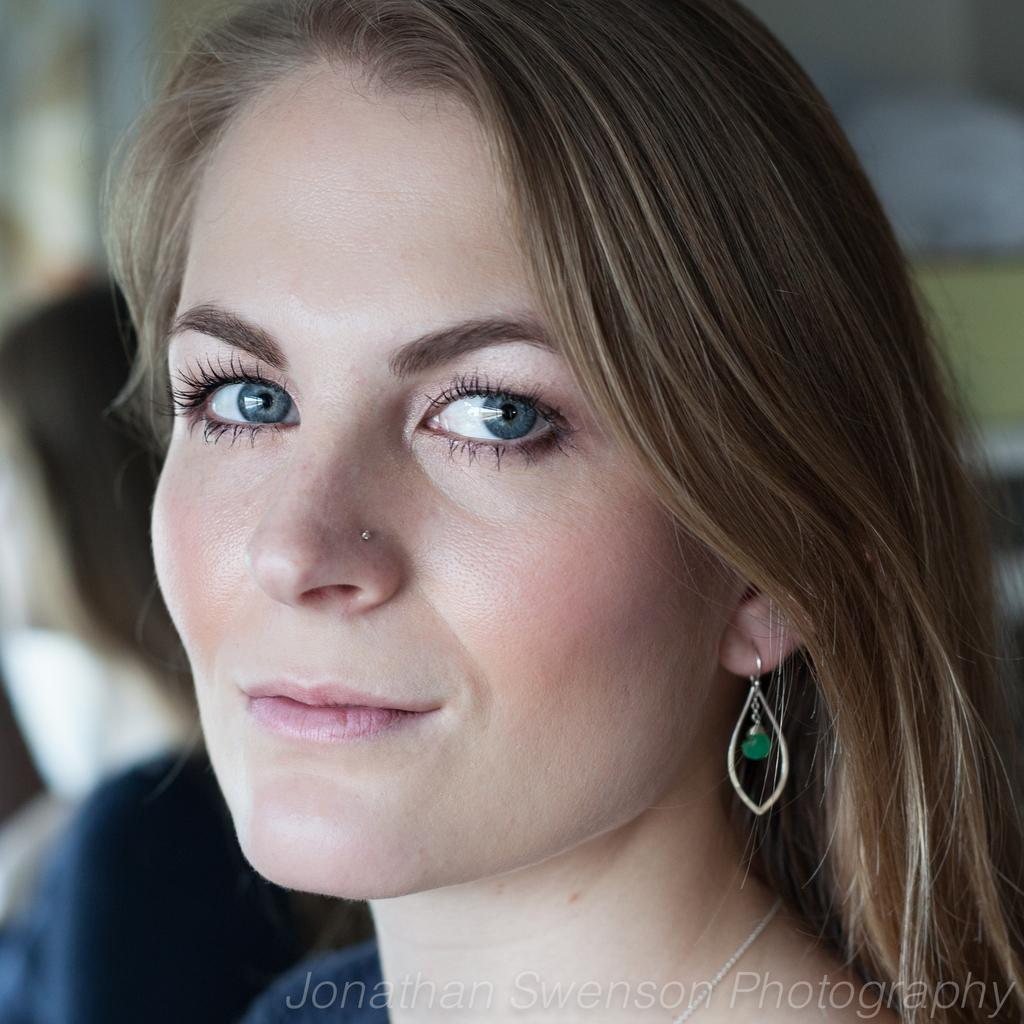Who is present in the image? There is a woman in the image. What is the woman's facial expression? The woman is smiling. What type of jewelry is the woman wearing? The woman is wearing a nose ring and an earring. How would you describe the background of the image? The background of the image appears blurry. Can you identify any additional features of the image? There is a watermark on the image. What type of drink does the woman hate in the image? There is no information about the woman's preferences or any drinks in the image. How does the woman slip on the ice in the image? There is no ice or any indication of the woman slipping in the image. 